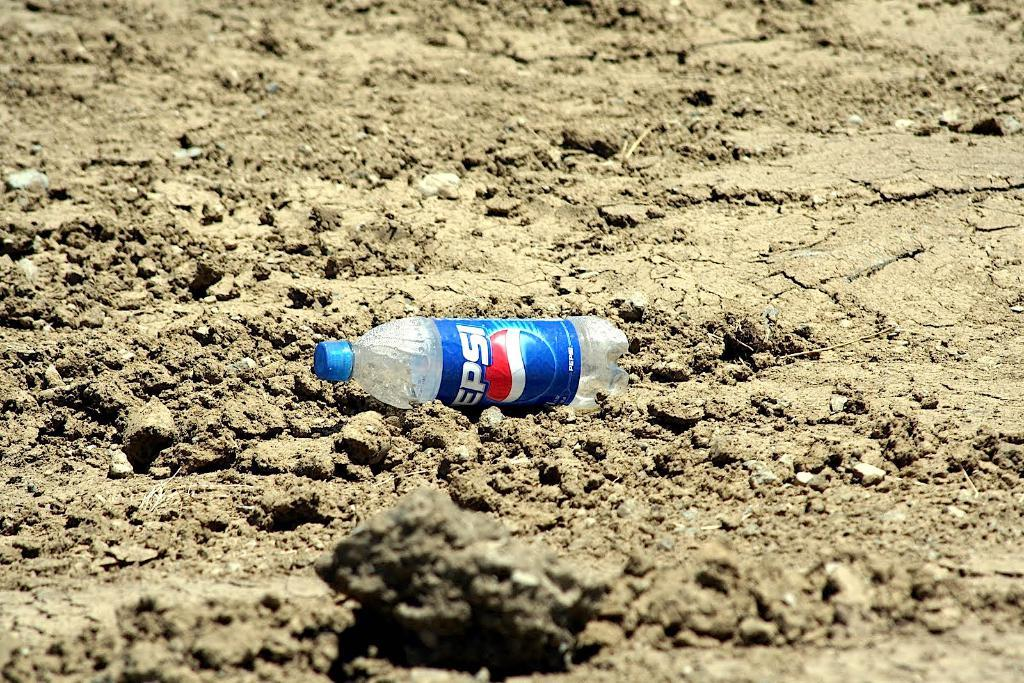<image>
Describe the image concisely. An empty Pepsi bottle lying in the dirt. 